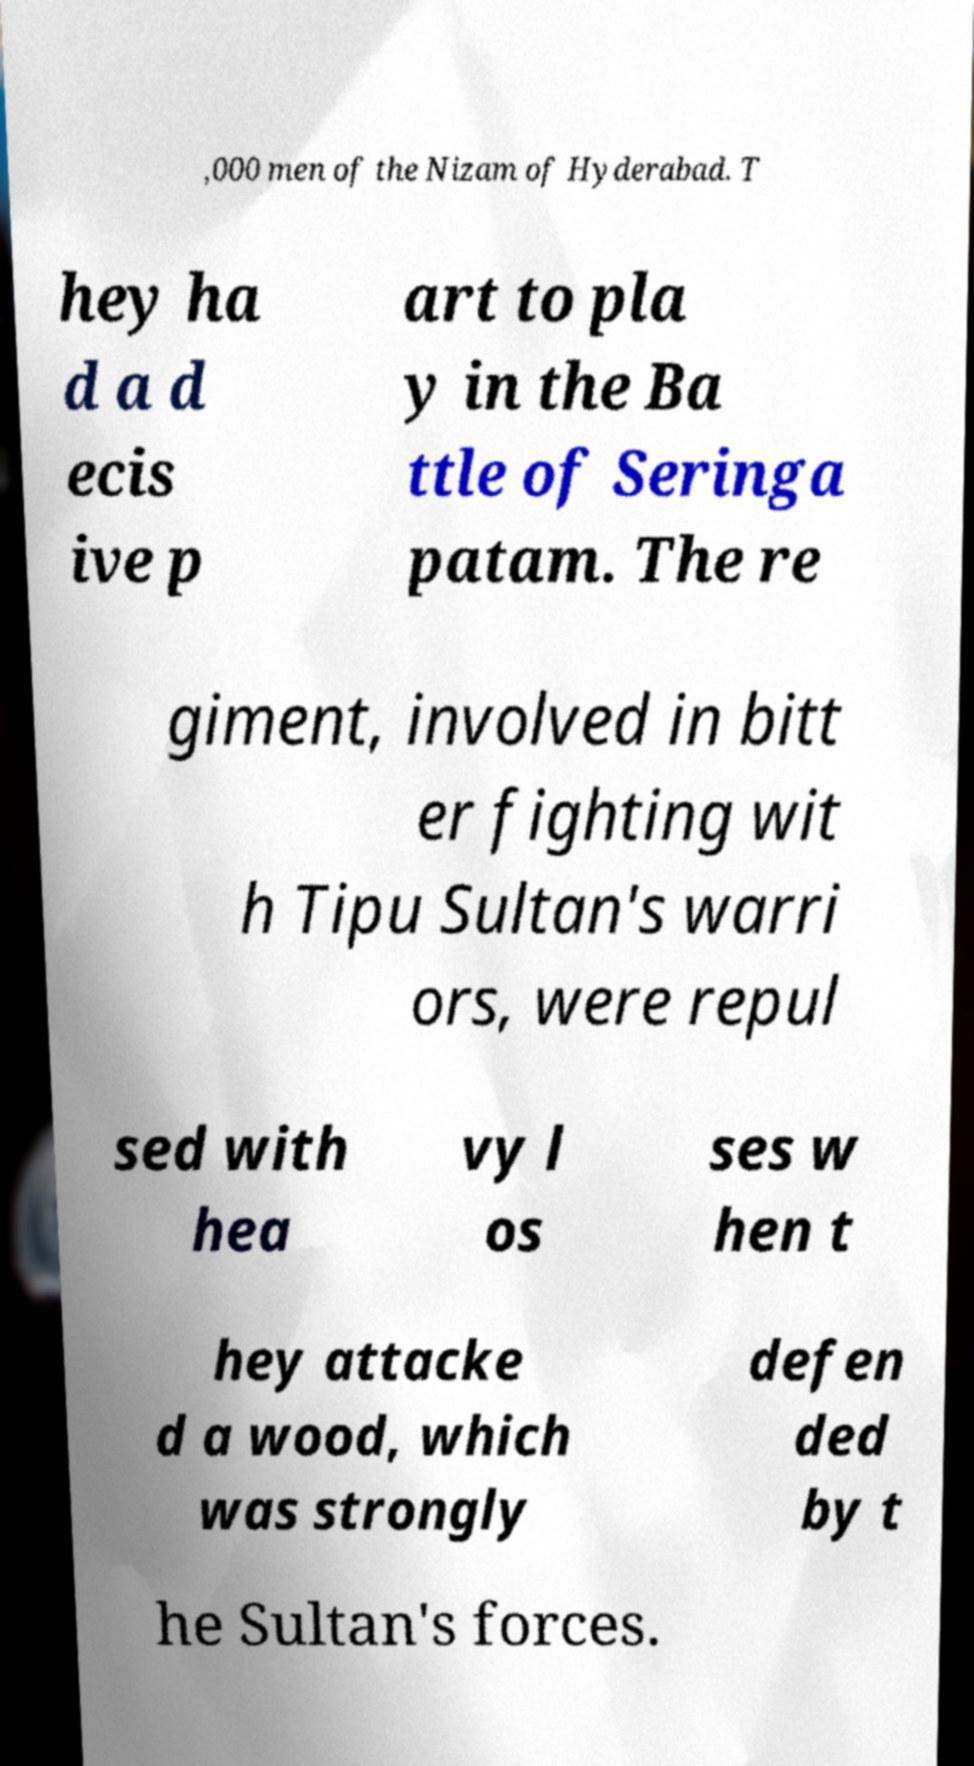Could you extract and type out the text from this image? ,000 men of the Nizam of Hyderabad. T hey ha d a d ecis ive p art to pla y in the Ba ttle of Seringa patam. The re giment, involved in bitt er fighting wit h Tipu Sultan's warri ors, were repul sed with hea vy l os ses w hen t hey attacke d a wood, which was strongly defen ded by t he Sultan's forces. 